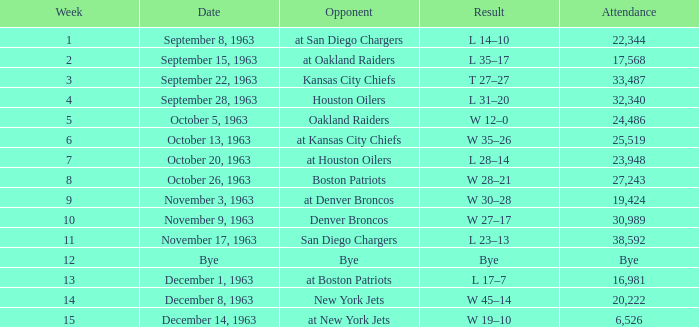Which adversary has a score of 14-10? At san diego chargers. 